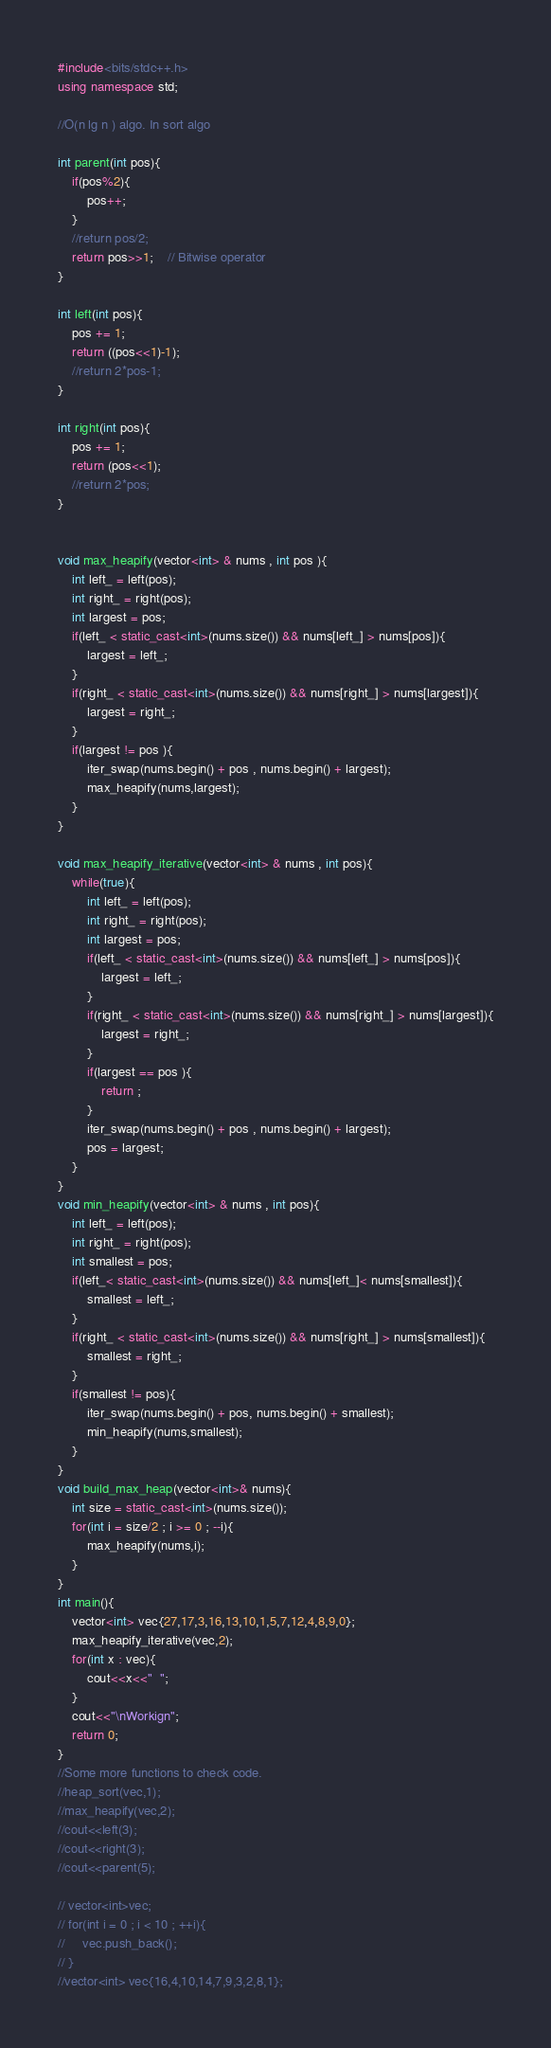<code> <loc_0><loc_0><loc_500><loc_500><_C++_>#include<bits/stdc++.h>
using namespace std;

//O(n lg n ) algo. In sort algo

int parent(int pos){
    if(pos%2){
        pos++;
    }
    //return pos/2;
    return pos>>1;    // Bitwise operator
}

int left(int pos){
    pos += 1;
    return ((pos<<1)-1);
    //return 2*pos-1;
}

int right(int pos){
    pos += 1;
    return (pos<<1);
    //return 2*pos;
}


void max_heapify(vector<int> & nums , int pos ){
    int left_ = left(pos);
    int right_ = right(pos);
    int largest = pos;
    if(left_ < static_cast<int>(nums.size()) && nums[left_] > nums[pos]){
        largest = left_;
    }
    if(right_ < static_cast<int>(nums.size()) && nums[right_] > nums[largest]){
        largest = right_;
    }
    if(largest != pos ){
        iter_swap(nums.begin() + pos , nums.begin() + largest);
        max_heapify(nums,largest);
    }
}

void max_heapify_iterative(vector<int> & nums , int pos){
    while(true){
        int left_ = left(pos);
        int right_ = right(pos);
        int largest = pos;
        if(left_ < static_cast<int>(nums.size()) && nums[left_] > nums[pos]){
            largest = left_;
        }
        if(right_ < static_cast<int>(nums.size()) && nums[right_] > nums[largest]){
            largest = right_;
        }
        if(largest == pos ){
            return ;
        }
        iter_swap(nums.begin() + pos , nums.begin() + largest);
        pos = largest;
    }
}
void min_heapify(vector<int> & nums , int pos){
    int left_ = left(pos);
    int right_ = right(pos);
    int smallest = pos;
    if(left_< static_cast<int>(nums.size()) && nums[left_]< nums[smallest]){
        smallest = left_;
    }
    if(right_ < static_cast<int>(nums.size()) && nums[right_] > nums[smallest]){
        smallest = right_;
    }
    if(smallest != pos){
        iter_swap(nums.begin() + pos, nums.begin() + smallest);
        min_heapify(nums,smallest);
    }
}
void build_max_heap(vector<int>& nums){
    int size = static_cast<int>(nums.size());
    for(int i = size/2 ; i >= 0 ; --i){
        max_heapify(nums,i);
    }
}
int main(){
    vector<int> vec{27,17,3,16,13,10,1,5,7,12,4,8,9,0};
    max_heapify_iterative(vec,2);
    for(int x : vec){
        cout<<x<<"  ";
    }
    cout<<"\nWorkign";
    return 0;
}
//Some more functions to check code.
//heap_sort(vec,1);
//max_heapify(vec,2);
//cout<<left(3);
//cout<<right(3);
//cout<<parent(5);

// vector<int>vec;
// for(int i = 0 ; i < 10 ; ++i){
//     vec.push_back();
// }
//vector<int> vec{16,4,10,14,7,9,3,2,8,1};
</code> 